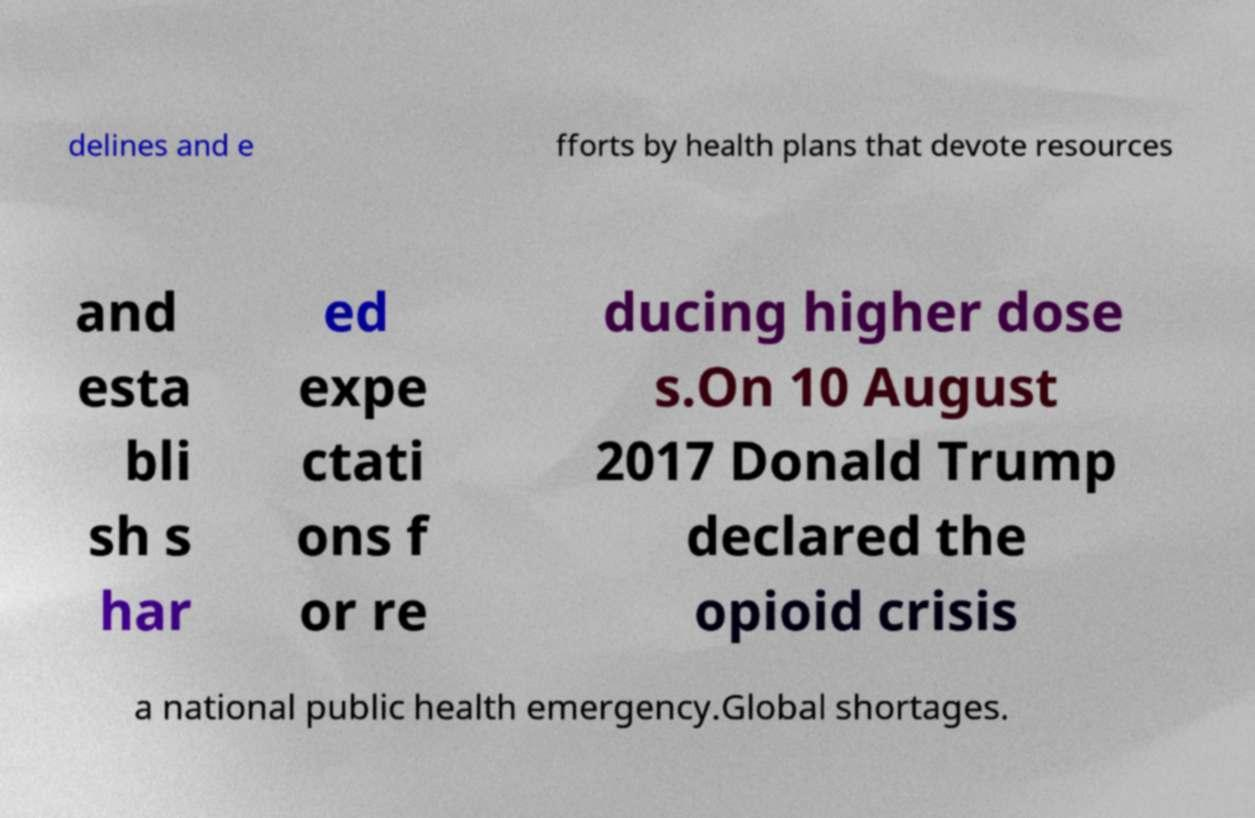I need the written content from this picture converted into text. Can you do that? delines and e fforts by health plans that devote resources and esta bli sh s har ed expe ctati ons f or re ducing higher dose s.On 10 August 2017 Donald Trump declared the opioid crisis a national public health emergency.Global shortages. 